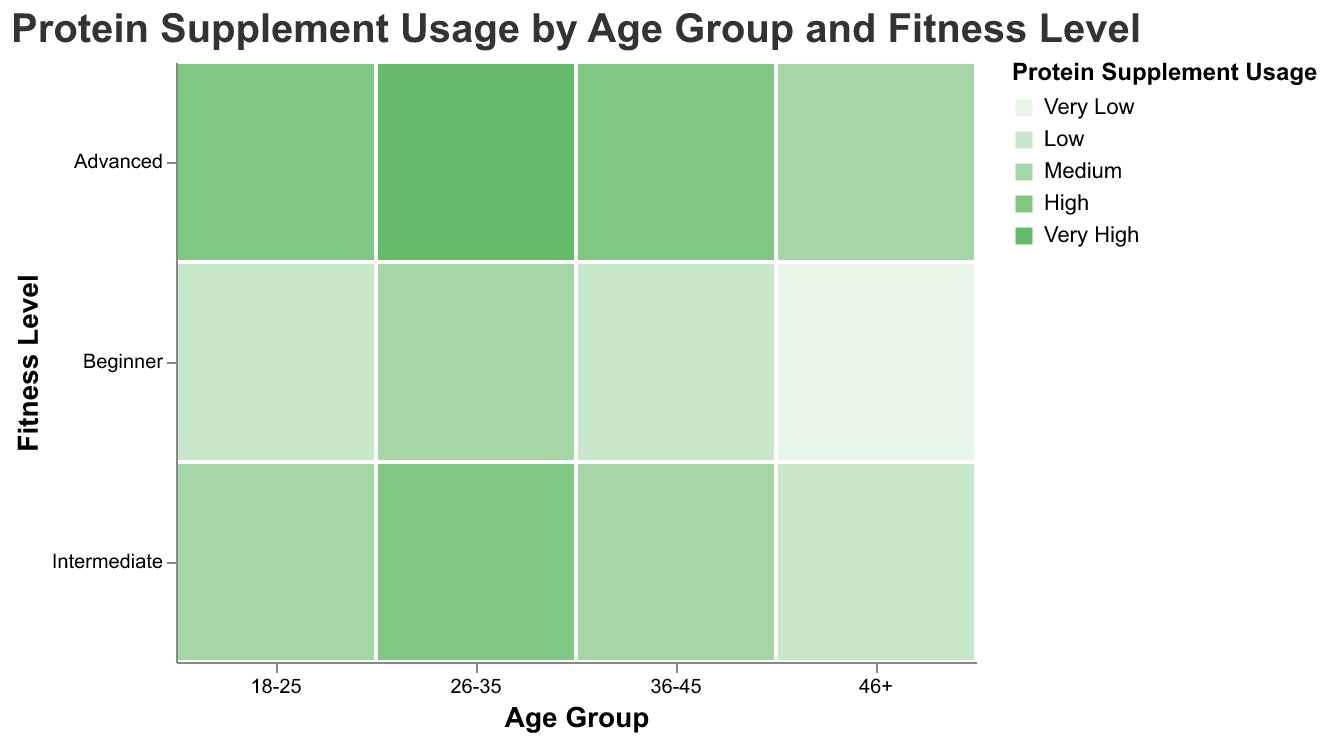What is the title of the figure? The figure title is displayed at the top of the plot, which clearly states what the entire visualization is about.
Answer: Protein Supplement Usage by Age Group and Fitness Level Which Age Group has the highest Protein Supplement Usage for Advanced Fitness Level? For an Advanced Fitness Level, inspect the color legends and match the color that represents the highest usage (Very High). The Age Group "26-35" has the darkest shade of green corresponding to Very High usage.
Answer: 26-35 How does Protein Supplement Usage vary for the 18-25 Age Group? For the 18-25 Age Group, observe the colors across different Fitness Levels. Beginners have Low usage, Intermediates have Medium usage, and Advanced individuals have High usage.
Answer: Beginner: Low, Intermediate: Medium, Advanced: High Is there any Age Group where Beginner Fitness Level has higher or equal Protein Supplement Usage compared to Advanced Fitness Level? Analyze each Age Group's Beginner and Advanced Fitness Levels. In the "46+" Age Group, Beginners have Very Low usage, which is lower than the Medium usage of Advanced individuals. For other Age Groups, Beginner's usage is also lower than Advanced.
Answer: No For which Age Group is the difference in Protein Supplement Usage between Beginner and Intermediate Fitness Levels most significant? Compare the colors for Beginner and Intermediate levels in each Age Group. The most significant difference appears in the "46+" Age Group where Beginners have Very Low usage and Intermediates have Low usage.
Answer: 46+ What is the least common Protein Supplement Usage level among Advanced fitness individuals across all Age Groups? Look at the colors for all Advanced Fitness Levels in each Age Group. All Advanced levels have at least Medium usage, thus Very Low and Low usages are absent in Advanced levels.
Answer: Very Low, Low Which Fitness Level has the same Protein Supplement Usage level across all Age Groups? Check each Fitness Level for consistent color coding across all Age Groups. Intermediate levels uniformly have Medium usage.
Answer: None What Age Group shows the highest variation in Protein Supplement Usage across different Fitness Levels? Evaluate the range of colors within each Age Group. The "26-35" Age Group spans from Medium (Beginner) to Very High (Advanced), indicating the highest variation.
Answer: 26-35 How does Protein Supplement Usage for Intermediate Fitness Level change with Age? Track the color progression for Intermediate Fitness Level from youngest to oldest Age Group: 18-25 (Medium), 26-35 (High), 36-45 (Medium), 46+ (Low).
Answer: Medium, High, Medium, Low In which Age Group does the Intermediate Fitness Level exceed the Advanced Fitness Level in Supplement Usage? Compare Intermediate and Advanced across each Age Group. No Age Group has Intermediate surpassing Advanced; Advanced usage is always higher or equal.
Answer: None 